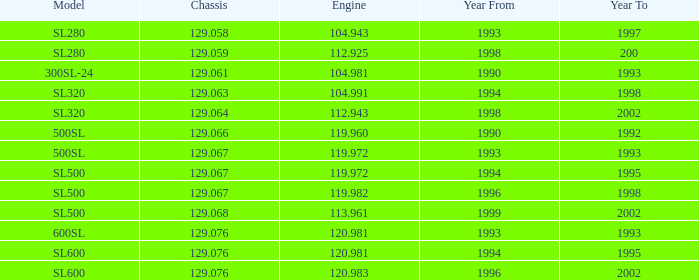Which Engine has a Model of sl500, and a Year From larger than 1999? None. 